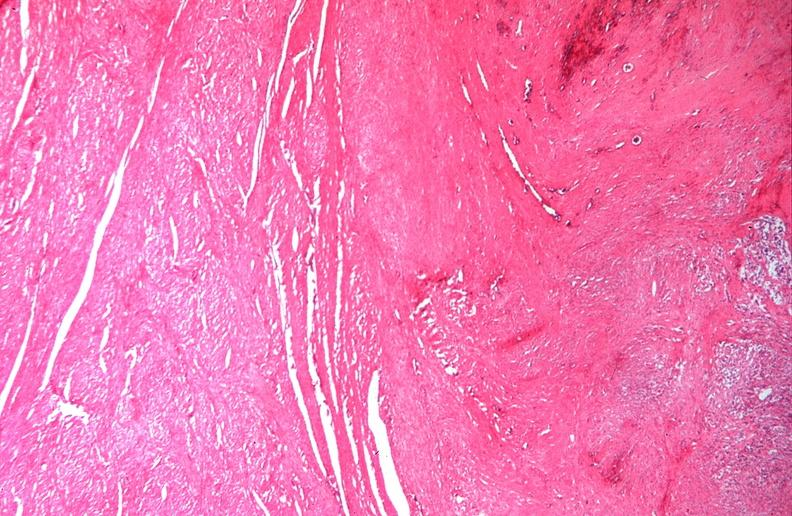s intraductal papillomatosis with apocrine metaplasia present?
Answer the question using a single word or phrase. No 